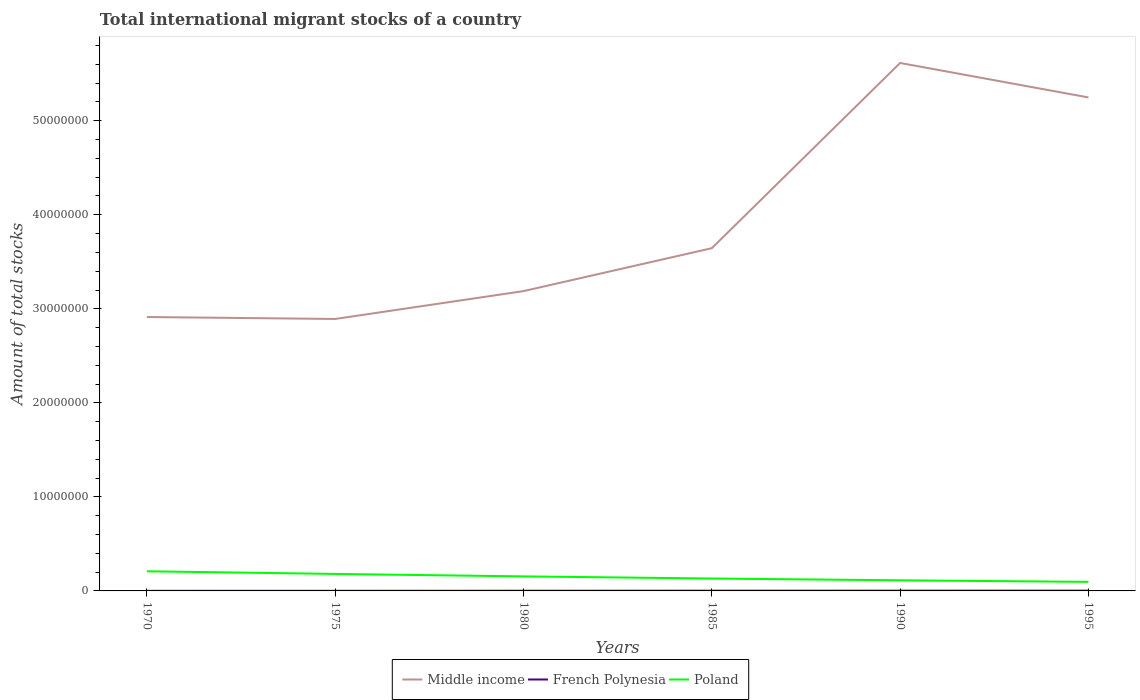How many different coloured lines are there?
Offer a terse response. 3. Does the line corresponding to French Polynesia intersect with the line corresponding to Poland?
Keep it short and to the point. No. Is the number of lines equal to the number of legend labels?
Your response must be concise. Yes. Across all years, what is the maximum amount of total stocks in in Middle income?
Your answer should be compact. 2.89e+07. In which year was the amount of total stocks in in Middle income maximum?
Offer a terse response. 1975. What is the total amount of total stocks in in Middle income in the graph?
Your response must be concise. -2.96e+06. What is the difference between the highest and the second highest amount of total stocks in in Middle income?
Offer a very short reply. 2.72e+07. What is the difference between the highest and the lowest amount of total stocks in in Poland?
Provide a short and direct response. 3. Is the amount of total stocks in in Poland strictly greater than the amount of total stocks in in French Polynesia over the years?
Offer a very short reply. No. Are the values on the major ticks of Y-axis written in scientific E-notation?
Make the answer very short. No. Does the graph contain any zero values?
Your answer should be very brief. No. What is the title of the graph?
Provide a short and direct response. Total international migrant stocks of a country. What is the label or title of the Y-axis?
Offer a very short reply. Amount of total stocks. What is the Amount of total stocks of Middle income in 1970?
Provide a short and direct response. 2.91e+07. What is the Amount of total stocks in French Polynesia in 1970?
Your response must be concise. 8194. What is the Amount of total stocks of Poland in 1970?
Keep it short and to the point. 2.09e+06. What is the Amount of total stocks of Middle income in 1975?
Offer a terse response. 2.89e+07. What is the Amount of total stocks in French Polynesia in 1975?
Your answer should be compact. 1.23e+04. What is the Amount of total stocks of Poland in 1975?
Keep it short and to the point. 1.81e+06. What is the Amount of total stocks of Middle income in 1980?
Provide a succinct answer. 3.19e+07. What is the Amount of total stocks in French Polynesia in 1980?
Ensure brevity in your answer.  1.80e+04. What is the Amount of total stocks in Poland in 1980?
Give a very brief answer. 1.54e+06. What is the Amount of total stocks in Middle income in 1985?
Your answer should be very brief. 3.64e+07. What is the Amount of total stocks of French Polynesia in 1985?
Ensure brevity in your answer.  2.37e+04. What is the Amount of total stocks of Poland in 1985?
Keep it short and to the point. 1.32e+06. What is the Amount of total stocks in Middle income in 1990?
Provide a short and direct response. 5.61e+07. What is the Amount of total stocks of French Polynesia in 1990?
Make the answer very short. 2.58e+04. What is the Amount of total stocks of Poland in 1990?
Provide a succinct answer. 1.13e+06. What is the Amount of total stocks in Middle income in 1995?
Your answer should be very brief. 5.25e+07. What is the Amount of total stocks of French Polynesia in 1995?
Your answer should be compact. 2.82e+04. What is the Amount of total stocks of Poland in 1995?
Give a very brief answer. 9.64e+05. Across all years, what is the maximum Amount of total stocks of Middle income?
Your answer should be very brief. 5.61e+07. Across all years, what is the maximum Amount of total stocks in French Polynesia?
Your answer should be compact. 2.82e+04. Across all years, what is the maximum Amount of total stocks in Poland?
Offer a terse response. 2.09e+06. Across all years, what is the minimum Amount of total stocks in Middle income?
Provide a short and direct response. 2.89e+07. Across all years, what is the minimum Amount of total stocks of French Polynesia?
Your response must be concise. 8194. Across all years, what is the minimum Amount of total stocks of Poland?
Provide a succinct answer. 9.64e+05. What is the total Amount of total stocks in Middle income in the graph?
Your response must be concise. 2.35e+08. What is the total Amount of total stocks of French Polynesia in the graph?
Offer a terse response. 1.16e+05. What is the total Amount of total stocks in Poland in the graph?
Give a very brief answer. 8.85e+06. What is the difference between the Amount of total stocks of Middle income in 1970 and that in 1975?
Offer a very short reply. 2.07e+05. What is the difference between the Amount of total stocks in French Polynesia in 1970 and that in 1975?
Ensure brevity in your answer.  -4058. What is the difference between the Amount of total stocks in Poland in 1970 and that in 1975?
Your answer should be compact. 2.80e+05. What is the difference between the Amount of total stocks of Middle income in 1970 and that in 1980?
Keep it short and to the point. -2.75e+06. What is the difference between the Amount of total stocks of French Polynesia in 1970 and that in 1980?
Provide a short and direct response. -9821. What is the difference between the Amount of total stocks of Poland in 1970 and that in 1980?
Your answer should be very brief. 5.43e+05. What is the difference between the Amount of total stocks of Middle income in 1970 and that in 1985?
Provide a succinct answer. -7.32e+06. What is the difference between the Amount of total stocks of French Polynesia in 1970 and that in 1985?
Provide a succinct answer. -1.55e+04. What is the difference between the Amount of total stocks of Poland in 1970 and that in 1985?
Your answer should be compact. 7.68e+05. What is the difference between the Amount of total stocks in Middle income in 1970 and that in 1990?
Provide a short and direct response. -2.70e+07. What is the difference between the Amount of total stocks in French Polynesia in 1970 and that in 1990?
Your answer should be compact. -1.76e+04. What is the difference between the Amount of total stocks in Poland in 1970 and that in 1990?
Your answer should be very brief. 9.60e+05. What is the difference between the Amount of total stocks of Middle income in 1970 and that in 1995?
Offer a terse response. -2.34e+07. What is the difference between the Amount of total stocks of French Polynesia in 1970 and that in 1995?
Your response must be concise. -2.00e+04. What is the difference between the Amount of total stocks of Poland in 1970 and that in 1995?
Your answer should be compact. 1.12e+06. What is the difference between the Amount of total stocks in Middle income in 1975 and that in 1980?
Ensure brevity in your answer.  -2.96e+06. What is the difference between the Amount of total stocks in French Polynesia in 1975 and that in 1980?
Provide a short and direct response. -5763. What is the difference between the Amount of total stocks in Poland in 1975 and that in 1980?
Give a very brief answer. 2.63e+05. What is the difference between the Amount of total stocks in Middle income in 1975 and that in 1985?
Provide a succinct answer. -7.53e+06. What is the difference between the Amount of total stocks in French Polynesia in 1975 and that in 1985?
Your answer should be very brief. -1.15e+04. What is the difference between the Amount of total stocks of Poland in 1975 and that in 1985?
Offer a very short reply. 4.88e+05. What is the difference between the Amount of total stocks in Middle income in 1975 and that in 1990?
Offer a very short reply. -2.72e+07. What is the difference between the Amount of total stocks in French Polynesia in 1975 and that in 1990?
Provide a short and direct response. -1.36e+04. What is the difference between the Amount of total stocks in Poland in 1975 and that in 1990?
Offer a terse response. 6.80e+05. What is the difference between the Amount of total stocks of Middle income in 1975 and that in 1995?
Keep it short and to the point. -2.36e+07. What is the difference between the Amount of total stocks of French Polynesia in 1975 and that in 1995?
Provide a short and direct response. -1.59e+04. What is the difference between the Amount of total stocks in Poland in 1975 and that in 1995?
Your answer should be compact. 8.44e+05. What is the difference between the Amount of total stocks in Middle income in 1980 and that in 1985?
Your response must be concise. -4.57e+06. What is the difference between the Amount of total stocks in French Polynesia in 1980 and that in 1985?
Make the answer very short. -5719. What is the difference between the Amount of total stocks of Poland in 1980 and that in 1985?
Ensure brevity in your answer.  2.25e+05. What is the difference between the Amount of total stocks of Middle income in 1980 and that in 1990?
Make the answer very short. -2.43e+07. What is the difference between the Amount of total stocks in French Polynesia in 1980 and that in 1990?
Give a very brief answer. -7815. What is the difference between the Amount of total stocks in Poland in 1980 and that in 1990?
Give a very brief answer. 4.17e+05. What is the difference between the Amount of total stocks in Middle income in 1980 and that in 1995?
Offer a very short reply. -2.06e+07. What is the difference between the Amount of total stocks in French Polynesia in 1980 and that in 1995?
Keep it short and to the point. -1.02e+04. What is the difference between the Amount of total stocks of Poland in 1980 and that in 1995?
Your answer should be very brief. 5.81e+05. What is the difference between the Amount of total stocks of Middle income in 1985 and that in 1990?
Ensure brevity in your answer.  -1.97e+07. What is the difference between the Amount of total stocks of French Polynesia in 1985 and that in 1990?
Give a very brief answer. -2096. What is the difference between the Amount of total stocks of Poland in 1985 and that in 1990?
Ensure brevity in your answer.  1.92e+05. What is the difference between the Amount of total stocks in Middle income in 1985 and that in 1995?
Keep it short and to the point. -1.60e+07. What is the difference between the Amount of total stocks of French Polynesia in 1985 and that in 1995?
Make the answer very short. -4455. What is the difference between the Amount of total stocks of Poland in 1985 and that in 1995?
Offer a terse response. 3.56e+05. What is the difference between the Amount of total stocks in Middle income in 1990 and that in 1995?
Keep it short and to the point. 3.66e+06. What is the difference between the Amount of total stocks in French Polynesia in 1990 and that in 1995?
Ensure brevity in your answer.  -2359. What is the difference between the Amount of total stocks in Poland in 1990 and that in 1995?
Offer a terse response. 1.64e+05. What is the difference between the Amount of total stocks in Middle income in 1970 and the Amount of total stocks in French Polynesia in 1975?
Keep it short and to the point. 2.91e+07. What is the difference between the Amount of total stocks in Middle income in 1970 and the Amount of total stocks in Poland in 1975?
Give a very brief answer. 2.73e+07. What is the difference between the Amount of total stocks in French Polynesia in 1970 and the Amount of total stocks in Poland in 1975?
Give a very brief answer. -1.80e+06. What is the difference between the Amount of total stocks in Middle income in 1970 and the Amount of total stocks in French Polynesia in 1980?
Ensure brevity in your answer.  2.91e+07. What is the difference between the Amount of total stocks in Middle income in 1970 and the Amount of total stocks in Poland in 1980?
Offer a very short reply. 2.76e+07. What is the difference between the Amount of total stocks of French Polynesia in 1970 and the Amount of total stocks of Poland in 1980?
Your response must be concise. -1.54e+06. What is the difference between the Amount of total stocks of Middle income in 1970 and the Amount of total stocks of French Polynesia in 1985?
Give a very brief answer. 2.91e+07. What is the difference between the Amount of total stocks of Middle income in 1970 and the Amount of total stocks of Poland in 1985?
Offer a terse response. 2.78e+07. What is the difference between the Amount of total stocks in French Polynesia in 1970 and the Amount of total stocks in Poland in 1985?
Keep it short and to the point. -1.31e+06. What is the difference between the Amount of total stocks of Middle income in 1970 and the Amount of total stocks of French Polynesia in 1990?
Ensure brevity in your answer.  2.91e+07. What is the difference between the Amount of total stocks in Middle income in 1970 and the Amount of total stocks in Poland in 1990?
Your answer should be very brief. 2.80e+07. What is the difference between the Amount of total stocks of French Polynesia in 1970 and the Amount of total stocks of Poland in 1990?
Provide a succinct answer. -1.12e+06. What is the difference between the Amount of total stocks in Middle income in 1970 and the Amount of total stocks in French Polynesia in 1995?
Your answer should be very brief. 2.91e+07. What is the difference between the Amount of total stocks in Middle income in 1970 and the Amount of total stocks in Poland in 1995?
Keep it short and to the point. 2.82e+07. What is the difference between the Amount of total stocks of French Polynesia in 1970 and the Amount of total stocks of Poland in 1995?
Keep it short and to the point. -9.55e+05. What is the difference between the Amount of total stocks in Middle income in 1975 and the Amount of total stocks in French Polynesia in 1980?
Ensure brevity in your answer.  2.89e+07. What is the difference between the Amount of total stocks in Middle income in 1975 and the Amount of total stocks in Poland in 1980?
Give a very brief answer. 2.74e+07. What is the difference between the Amount of total stocks of French Polynesia in 1975 and the Amount of total stocks of Poland in 1980?
Provide a succinct answer. -1.53e+06. What is the difference between the Amount of total stocks of Middle income in 1975 and the Amount of total stocks of French Polynesia in 1985?
Your response must be concise. 2.89e+07. What is the difference between the Amount of total stocks in Middle income in 1975 and the Amount of total stocks in Poland in 1985?
Offer a very short reply. 2.76e+07. What is the difference between the Amount of total stocks in French Polynesia in 1975 and the Amount of total stocks in Poland in 1985?
Keep it short and to the point. -1.31e+06. What is the difference between the Amount of total stocks of Middle income in 1975 and the Amount of total stocks of French Polynesia in 1990?
Make the answer very short. 2.89e+07. What is the difference between the Amount of total stocks in Middle income in 1975 and the Amount of total stocks in Poland in 1990?
Ensure brevity in your answer.  2.78e+07. What is the difference between the Amount of total stocks of French Polynesia in 1975 and the Amount of total stocks of Poland in 1990?
Keep it short and to the point. -1.12e+06. What is the difference between the Amount of total stocks of Middle income in 1975 and the Amount of total stocks of French Polynesia in 1995?
Ensure brevity in your answer.  2.89e+07. What is the difference between the Amount of total stocks in Middle income in 1975 and the Amount of total stocks in Poland in 1995?
Ensure brevity in your answer.  2.80e+07. What is the difference between the Amount of total stocks in French Polynesia in 1975 and the Amount of total stocks in Poland in 1995?
Provide a succinct answer. -9.51e+05. What is the difference between the Amount of total stocks in Middle income in 1980 and the Amount of total stocks in French Polynesia in 1985?
Offer a very short reply. 3.19e+07. What is the difference between the Amount of total stocks in Middle income in 1980 and the Amount of total stocks in Poland in 1985?
Ensure brevity in your answer.  3.06e+07. What is the difference between the Amount of total stocks in French Polynesia in 1980 and the Amount of total stocks in Poland in 1985?
Offer a very short reply. -1.30e+06. What is the difference between the Amount of total stocks of Middle income in 1980 and the Amount of total stocks of French Polynesia in 1990?
Provide a short and direct response. 3.19e+07. What is the difference between the Amount of total stocks of Middle income in 1980 and the Amount of total stocks of Poland in 1990?
Offer a terse response. 3.08e+07. What is the difference between the Amount of total stocks of French Polynesia in 1980 and the Amount of total stocks of Poland in 1990?
Provide a succinct answer. -1.11e+06. What is the difference between the Amount of total stocks in Middle income in 1980 and the Amount of total stocks in French Polynesia in 1995?
Provide a short and direct response. 3.19e+07. What is the difference between the Amount of total stocks of Middle income in 1980 and the Amount of total stocks of Poland in 1995?
Give a very brief answer. 3.09e+07. What is the difference between the Amount of total stocks of French Polynesia in 1980 and the Amount of total stocks of Poland in 1995?
Make the answer very short. -9.46e+05. What is the difference between the Amount of total stocks in Middle income in 1985 and the Amount of total stocks in French Polynesia in 1990?
Ensure brevity in your answer.  3.64e+07. What is the difference between the Amount of total stocks of Middle income in 1985 and the Amount of total stocks of Poland in 1990?
Ensure brevity in your answer.  3.53e+07. What is the difference between the Amount of total stocks in French Polynesia in 1985 and the Amount of total stocks in Poland in 1990?
Keep it short and to the point. -1.10e+06. What is the difference between the Amount of total stocks of Middle income in 1985 and the Amount of total stocks of French Polynesia in 1995?
Offer a terse response. 3.64e+07. What is the difference between the Amount of total stocks in Middle income in 1985 and the Amount of total stocks in Poland in 1995?
Keep it short and to the point. 3.55e+07. What is the difference between the Amount of total stocks of French Polynesia in 1985 and the Amount of total stocks of Poland in 1995?
Your answer should be very brief. -9.40e+05. What is the difference between the Amount of total stocks in Middle income in 1990 and the Amount of total stocks in French Polynesia in 1995?
Offer a terse response. 5.61e+07. What is the difference between the Amount of total stocks of Middle income in 1990 and the Amount of total stocks of Poland in 1995?
Your response must be concise. 5.52e+07. What is the difference between the Amount of total stocks in French Polynesia in 1990 and the Amount of total stocks in Poland in 1995?
Your answer should be very brief. -9.38e+05. What is the average Amount of total stocks of Middle income per year?
Your answer should be compact. 3.92e+07. What is the average Amount of total stocks in French Polynesia per year?
Provide a short and direct response. 1.94e+04. What is the average Amount of total stocks of Poland per year?
Keep it short and to the point. 1.48e+06. In the year 1970, what is the difference between the Amount of total stocks of Middle income and Amount of total stocks of French Polynesia?
Provide a short and direct response. 2.91e+07. In the year 1970, what is the difference between the Amount of total stocks in Middle income and Amount of total stocks in Poland?
Your response must be concise. 2.70e+07. In the year 1970, what is the difference between the Amount of total stocks in French Polynesia and Amount of total stocks in Poland?
Your response must be concise. -2.08e+06. In the year 1975, what is the difference between the Amount of total stocks in Middle income and Amount of total stocks in French Polynesia?
Ensure brevity in your answer.  2.89e+07. In the year 1975, what is the difference between the Amount of total stocks in Middle income and Amount of total stocks in Poland?
Your answer should be compact. 2.71e+07. In the year 1975, what is the difference between the Amount of total stocks in French Polynesia and Amount of total stocks in Poland?
Offer a terse response. -1.80e+06. In the year 1980, what is the difference between the Amount of total stocks of Middle income and Amount of total stocks of French Polynesia?
Provide a succinct answer. 3.19e+07. In the year 1980, what is the difference between the Amount of total stocks of Middle income and Amount of total stocks of Poland?
Your answer should be very brief. 3.03e+07. In the year 1980, what is the difference between the Amount of total stocks in French Polynesia and Amount of total stocks in Poland?
Provide a short and direct response. -1.53e+06. In the year 1985, what is the difference between the Amount of total stocks in Middle income and Amount of total stocks in French Polynesia?
Your answer should be compact. 3.64e+07. In the year 1985, what is the difference between the Amount of total stocks in Middle income and Amount of total stocks in Poland?
Offer a terse response. 3.51e+07. In the year 1985, what is the difference between the Amount of total stocks in French Polynesia and Amount of total stocks in Poland?
Offer a terse response. -1.30e+06. In the year 1990, what is the difference between the Amount of total stocks of Middle income and Amount of total stocks of French Polynesia?
Ensure brevity in your answer.  5.61e+07. In the year 1990, what is the difference between the Amount of total stocks in Middle income and Amount of total stocks in Poland?
Give a very brief answer. 5.50e+07. In the year 1990, what is the difference between the Amount of total stocks of French Polynesia and Amount of total stocks of Poland?
Your answer should be very brief. -1.10e+06. In the year 1995, what is the difference between the Amount of total stocks in Middle income and Amount of total stocks in French Polynesia?
Offer a terse response. 5.25e+07. In the year 1995, what is the difference between the Amount of total stocks of Middle income and Amount of total stocks of Poland?
Offer a terse response. 5.15e+07. In the year 1995, what is the difference between the Amount of total stocks of French Polynesia and Amount of total stocks of Poland?
Make the answer very short. -9.35e+05. What is the ratio of the Amount of total stocks of Middle income in 1970 to that in 1975?
Ensure brevity in your answer.  1.01. What is the ratio of the Amount of total stocks in French Polynesia in 1970 to that in 1975?
Your answer should be compact. 0.67. What is the ratio of the Amount of total stocks in Poland in 1970 to that in 1975?
Offer a terse response. 1.15. What is the ratio of the Amount of total stocks in Middle income in 1970 to that in 1980?
Give a very brief answer. 0.91. What is the ratio of the Amount of total stocks of French Polynesia in 1970 to that in 1980?
Offer a very short reply. 0.45. What is the ratio of the Amount of total stocks of Poland in 1970 to that in 1980?
Provide a short and direct response. 1.35. What is the ratio of the Amount of total stocks of Middle income in 1970 to that in 1985?
Give a very brief answer. 0.8. What is the ratio of the Amount of total stocks in French Polynesia in 1970 to that in 1985?
Give a very brief answer. 0.35. What is the ratio of the Amount of total stocks in Poland in 1970 to that in 1985?
Provide a succinct answer. 1.58. What is the ratio of the Amount of total stocks in Middle income in 1970 to that in 1990?
Keep it short and to the point. 0.52. What is the ratio of the Amount of total stocks of French Polynesia in 1970 to that in 1990?
Ensure brevity in your answer.  0.32. What is the ratio of the Amount of total stocks of Poland in 1970 to that in 1990?
Keep it short and to the point. 1.85. What is the ratio of the Amount of total stocks in Middle income in 1970 to that in 1995?
Offer a terse response. 0.56. What is the ratio of the Amount of total stocks of French Polynesia in 1970 to that in 1995?
Provide a succinct answer. 0.29. What is the ratio of the Amount of total stocks of Poland in 1970 to that in 1995?
Your response must be concise. 2.17. What is the ratio of the Amount of total stocks of Middle income in 1975 to that in 1980?
Offer a terse response. 0.91. What is the ratio of the Amount of total stocks in French Polynesia in 1975 to that in 1980?
Ensure brevity in your answer.  0.68. What is the ratio of the Amount of total stocks of Poland in 1975 to that in 1980?
Your answer should be compact. 1.17. What is the ratio of the Amount of total stocks of Middle income in 1975 to that in 1985?
Provide a succinct answer. 0.79. What is the ratio of the Amount of total stocks of French Polynesia in 1975 to that in 1985?
Give a very brief answer. 0.52. What is the ratio of the Amount of total stocks in Poland in 1975 to that in 1985?
Ensure brevity in your answer.  1.37. What is the ratio of the Amount of total stocks in Middle income in 1975 to that in 1990?
Offer a terse response. 0.52. What is the ratio of the Amount of total stocks in French Polynesia in 1975 to that in 1990?
Provide a succinct answer. 0.47. What is the ratio of the Amount of total stocks of Poland in 1975 to that in 1990?
Your response must be concise. 1.6. What is the ratio of the Amount of total stocks in Middle income in 1975 to that in 1995?
Your answer should be very brief. 0.55. What is the ratio of the Amount of total stocks in French Polynesia in 1975 to that in 1995?
Offer a very short reply. 0.43. What is the ratio of the Amount of total stocks of Poland in 1975 to that in 1995?
Provide a succinct answer. 1.88. What is the ratio of the Amount of total stocks of Middle income in 1980 to that in 1985?
Your answer should be compact. 0.87. What is the ratio of the Amount of total stocks in French Polynesia in 1980 to that in 1985?
Provide a succinct answer. 0.76. What is the ratio of the Amount of total stocks in Poland in 1980 to that in 1985?
Keep it short and to the point. 1.17. What is the ratio of the Amount of total stocks in Middle income in 1980 to that in 1990?
Your response must be concise. 0.57. What is the ratio of the Amount of total stocks in French Polynesia in 1980 to that in 1990?
Offer a very short reply. 0.7. What is the ratio of the Amount of total stocks in Poland in 1980 to that in 1990?
Provide a short and direct response. 1.37. What is the ratio of the Amount of total stocks of Middle income in 1980 to that in 1995?
Your response must be concise. 0.61. What is the ratio of the Amount of total stocks of French Polynesia in 1980 to that in 1995?
Your answer should be compact. 0.64. What is the ratio of the Amount of total stocks of Poland in 1980 to that in 1995?
Provide a succinct answer. 1.6. What is the ratio of the Amount of total stocks in Middle income in 1985 to that in 1990?
Give a very brief answer. 0.65. What is the ratio of the Amount of total stocks of French Polynesia in 1985 to that in 1990?
Provide a succinct answer. 0.92. What is the ratio of the Amount of total stocks of Poland in 1985 to that in 1990?
Your answer should be compact. 1.17. What is the ratio of the Amount of total stocks of Middle income in 1985 to that in 1995?
Offer a very short reply. 0.69. What is the ratio of the Amount of total stocks of French Polynesia in 1985 to that in 1995?
Your answer should be compact. 0.84. What is the ratio of the Amount of total stocks of Poland in 1985 to that in 1995?
Make the answer very short. 1.37. What is the ratio of the Amount of total stocks in Middle income in 1990 to that in 1995?
Give a very brief answer. 1.07. What is the ratio of the Amount of total stocks of French Polynesia in 1990 to that in 1995?
Your answer should be very brief. 0.92. What is the ratio of the Amount of total stocks of Poland in 1990 to that in 1995?
Ensure brevity in your answer.  1.17. What is the difference between the highest and the second highest Amount of total stocks in Middle income?
Your answer should be very brief. 3.66e+06. What is the difference between the highest and the second highest Amount of total stocks of French Polynesia?
Your response must be concise. 2359. What is the difference between the highest and the second highest Amount of total stocks in Poland?
Provide a short and direct response. 2.80e+05. What is the difference between the highest and the lowest Amount of total stocks in Middle income?
Offer a terse response. 2.72e+07. What is the difference between the highest and the lowest Amount of total stocks of French Polynesia?
Your answer should be very brief. 2.00e+04. What is the difference between the highest and the lowest Amount of total stocks in Poland?
Your answer should be very brief. 1.12e+06. 